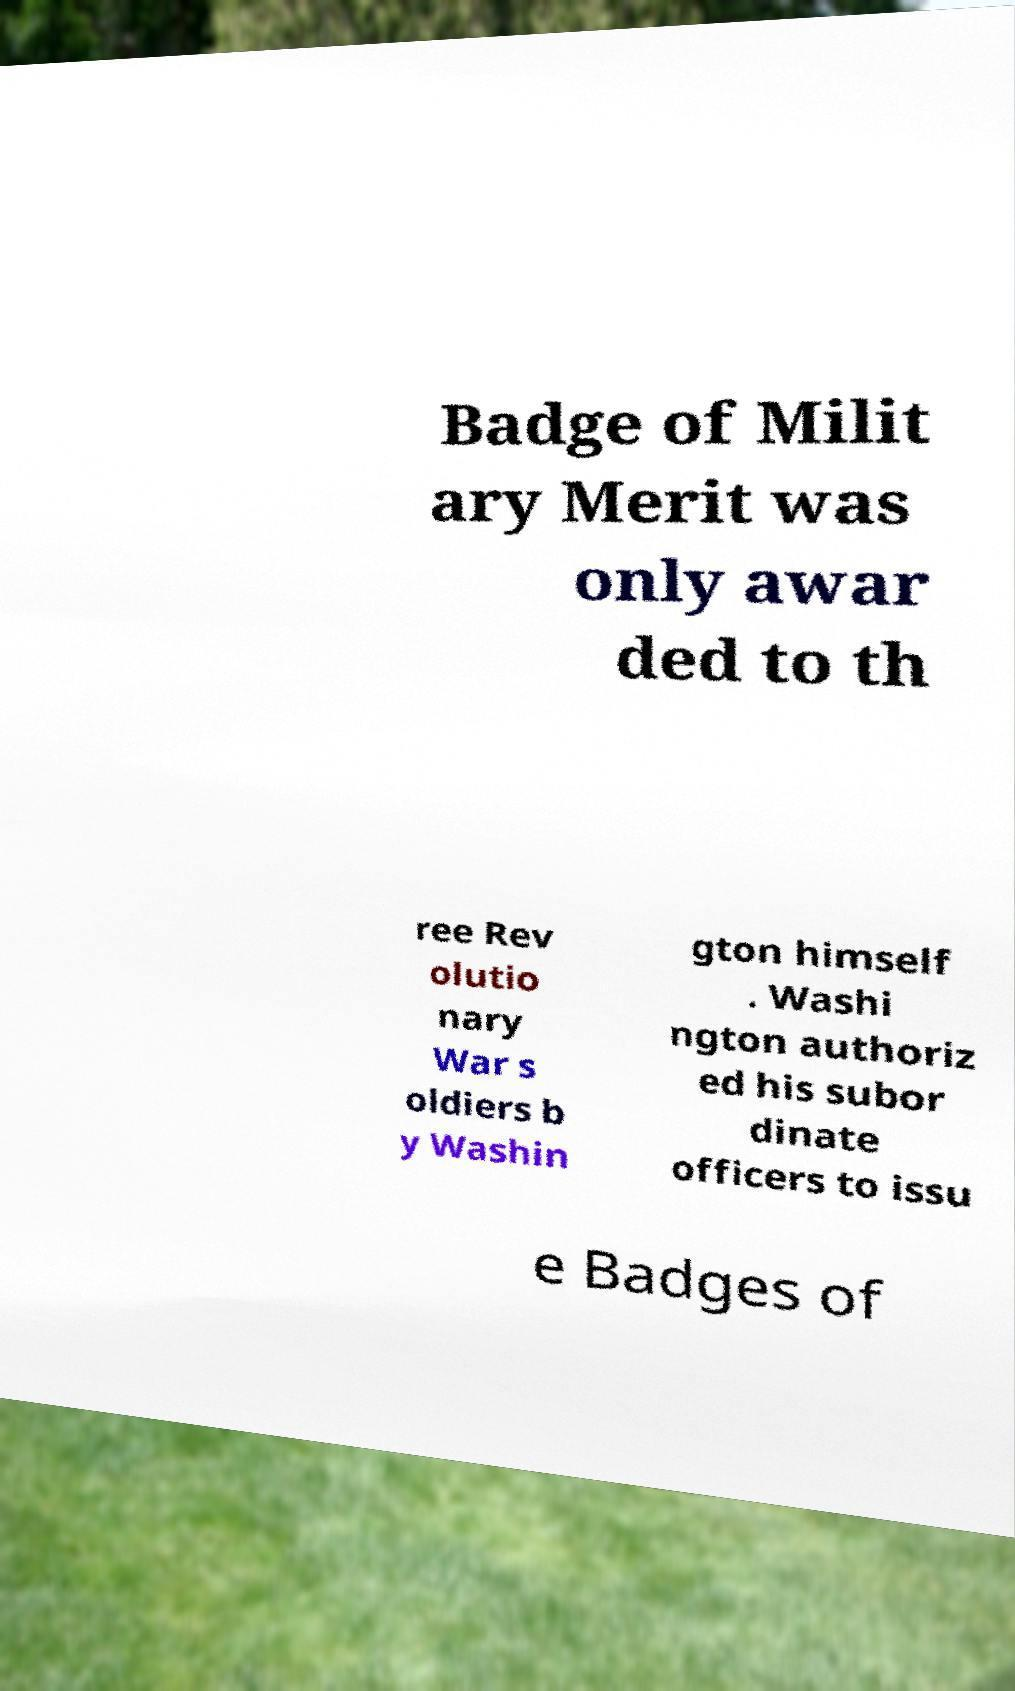Please identify and transcribe the text found in this image. Badge of Milit ary Merit was only awar ded to th ree Rev olutio nary War s oldiers b y Washin gton himself . Washi ngton authoriz ed his subor dinate officers to issu e Badges of 